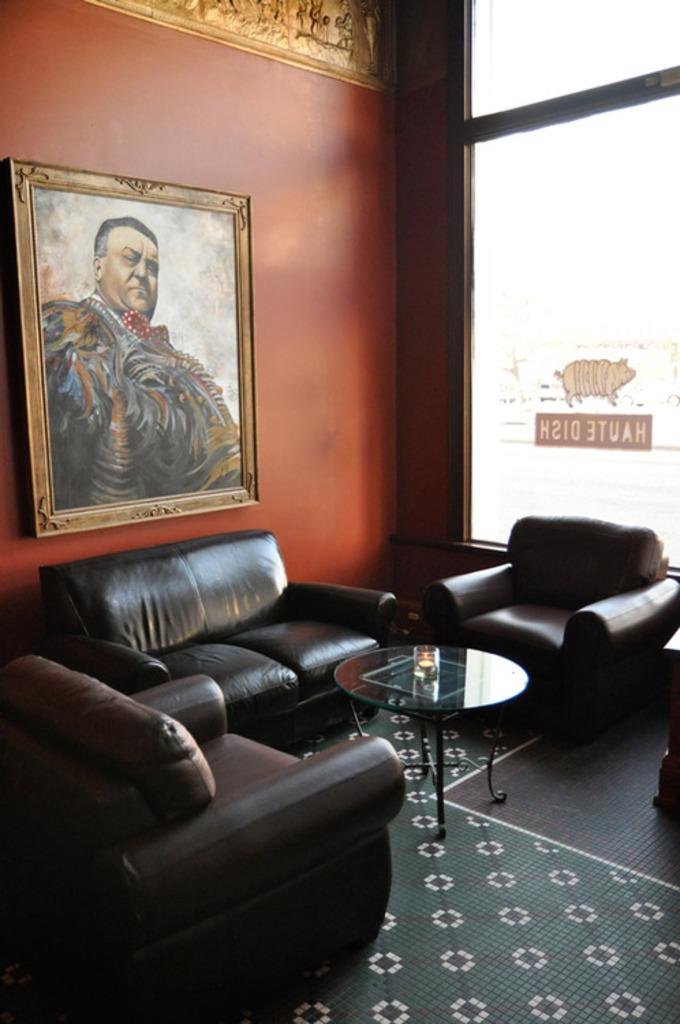What is attached to the wall in the image? There is a frame attached to a wall in the image. What type of furniture is present in the image? There is a couch and a chair in the image. What type of floor covering is visible in the image? There is a carpet in the image. What type of surface is present in the image for placing objects? There is a table in the image. What type of object made of glass can be seen in the image? There is a glass object in the image. What type of artwork is visible in the background of the image? There is a sculpture in the background of the image. What type of decoration is attached to a building in the background of the image? There is a sticker attached to a building in the background of the image. What type of oatmeal is being served on the table in the image? There is no oatmeal present in the image. What point is the sculpture trying to make in the background of the image? The sculpture is not trying to make a point; it is a piece of artwork. 